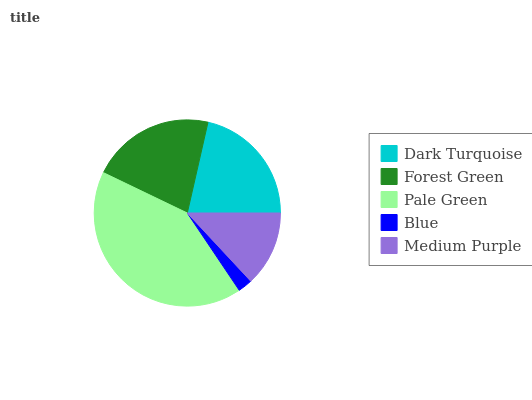Is Blue the minimum?
Answer yes or no. Yes. Is Pale Green the maximum?
Answer yes or no. Yes. Is Forest Green the minimum?
Answer yes or no. No. Is Forest Green the maximum?
Answer yes or no. No. Is Dark Turquoise greater than Forest Green?
Answer yes or no. Yes. Is Forest Green less than Dark Turquoise?
Answer yes or no. Yes. Is Forest Green greater than Dark Turquoise?
Answer yes or no. No. Is Dark Turquoise less than Forest Green?
Answer yes or no. No. Is Forest Green the high median?
Answer yes or no. Yes. Is Forest Green the low median?
Answer yes or no. Yes. Is Pale Green the high median?
Answer yes or no. No. Is Pale Green the low median?
Answer yes or no. No. 